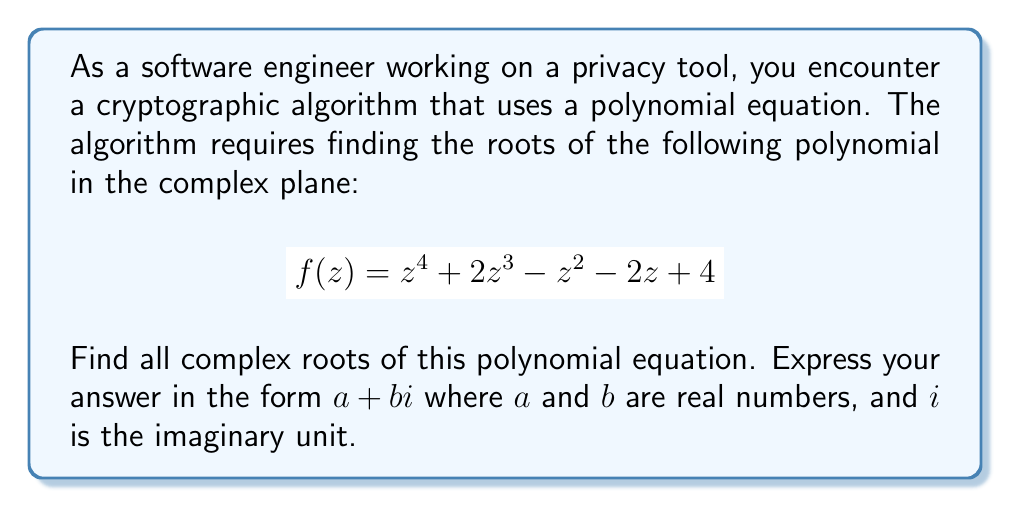Provide a solution to this math problem. To find the roots of this polynomial, we'll use the following steps:

1) First, we should check if there are any rational roots using the rational root theorem. The possible rational roots are the factors of the constant term: $\pm 1, \pm 2, \pm 4$. By testing these, we find that $z = -1$ is a root.

2) We can factor out $(z+1)$ from the polynomial:

   $$f(z) = (z+1)(z^3 + z^2 - 2z - 4)$$

3) Now we need to solve the cubic equation $z^3 + z^2 - 2z - 4 = 0$. We can use the rational root theorem again, and we find that $z = 2$ is a root.

4) We can factor out $(z-2)$ from the cubic:

   $$z^3 + z^2 - 2z - 4 = (z-2)(z^2 + 3z + 2)$$

5) Now we're left with a quadratic equation: $z^2 + 3z + 2 = 0$

6) We can solve this using the quadratic formula: $z = \frac{-b \pm \sqrt{b^2 - 4ac}}{2a}$

   $$z = \frac{-3 \pm \sqrt{3^2 - 4(1)(2)}}{2(1)} = \frac{-3 \pm \sqrt{1}}{2} = \frac{-3 \pm 1}{2}$$

7) This gives us the final two roots: $z = -1$ and $z = -2$

Therefore, the four roots of the polynomial are:

$z_1 = -1$
$z_2 = 2$
$z_3 = -1$
$z_4 = -2$

All of these roots are real numbers, so their imaginary parts are 0.
Answer: The roots of the polynomial $f(z) = z^4 + 2z^3 - z^2 - 2z + 4$ are:

$z_1 = -1 + 0i$
$z_2 = 2 + 0i$
$z_3 = -1 + 0i$
$z_4 = -2 + 0i$ 